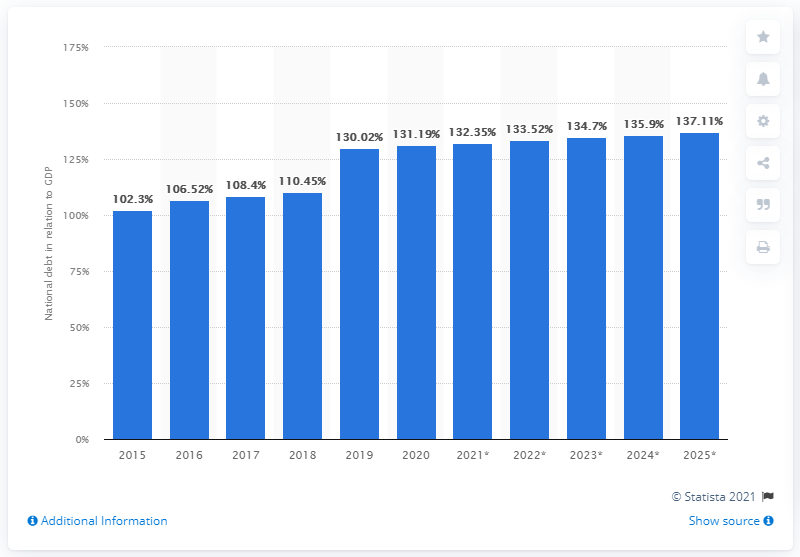Outline some significant characteristics in this image. In 2020, the national debt of Singapore accounted for approximately 84.1% of the country's GDP. 